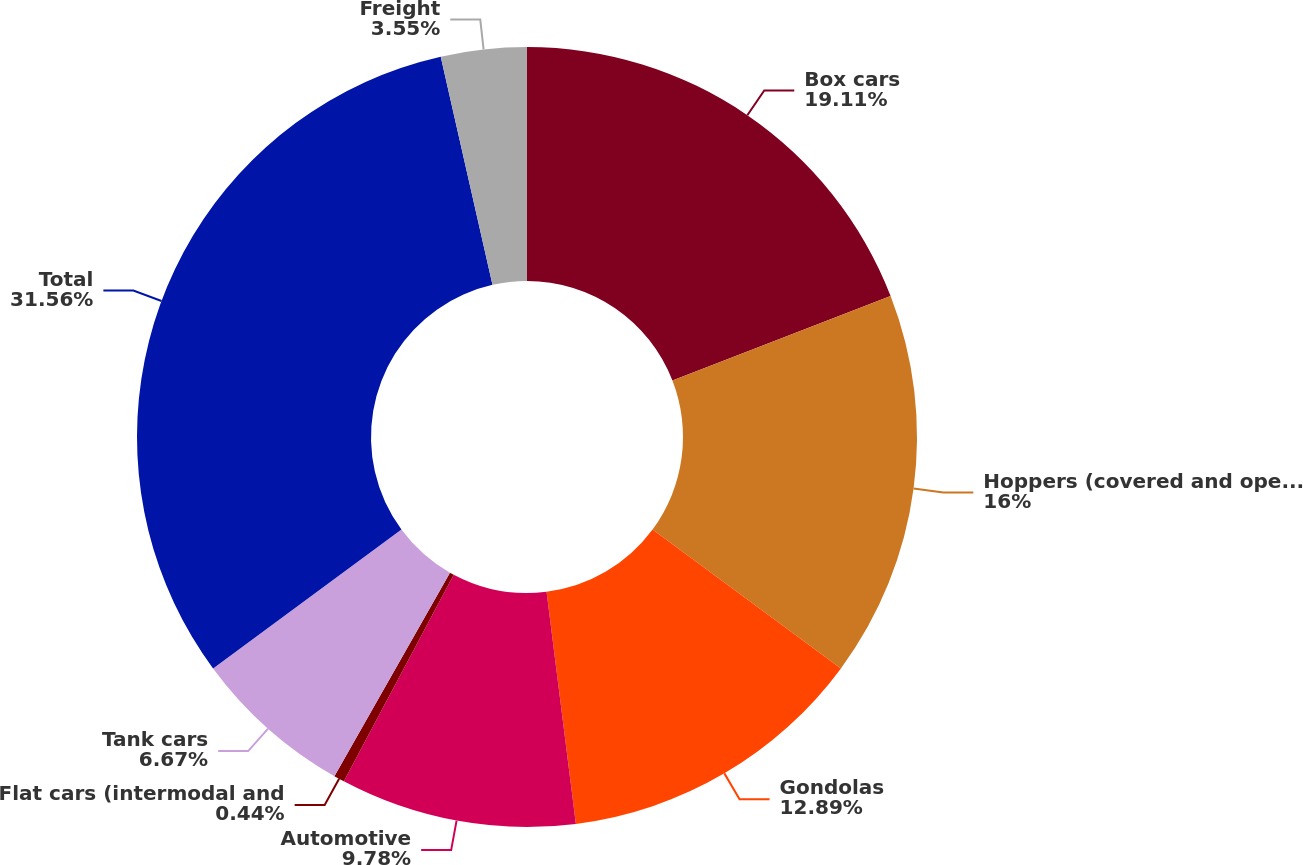Convert chart to OTSL. <chart><loc_0><loc_0><loc_500><loc_500><pie_chart><fcel>Box cars<fcel>Hoppers (covered and open top)<fcel>Gondolas<fcel>Automotive<fcel>Flat cars (intermodal and<fcel>Tank cars<fcel>Total<fcel>Freight<nl><fcel>19.11%<fcel>16.0%<fcel>12.89%<fcel>9.78%<fcel>0.44%<fcel>6.67%<fcel>31.56%<fcel>3.55%<nl></chart> 